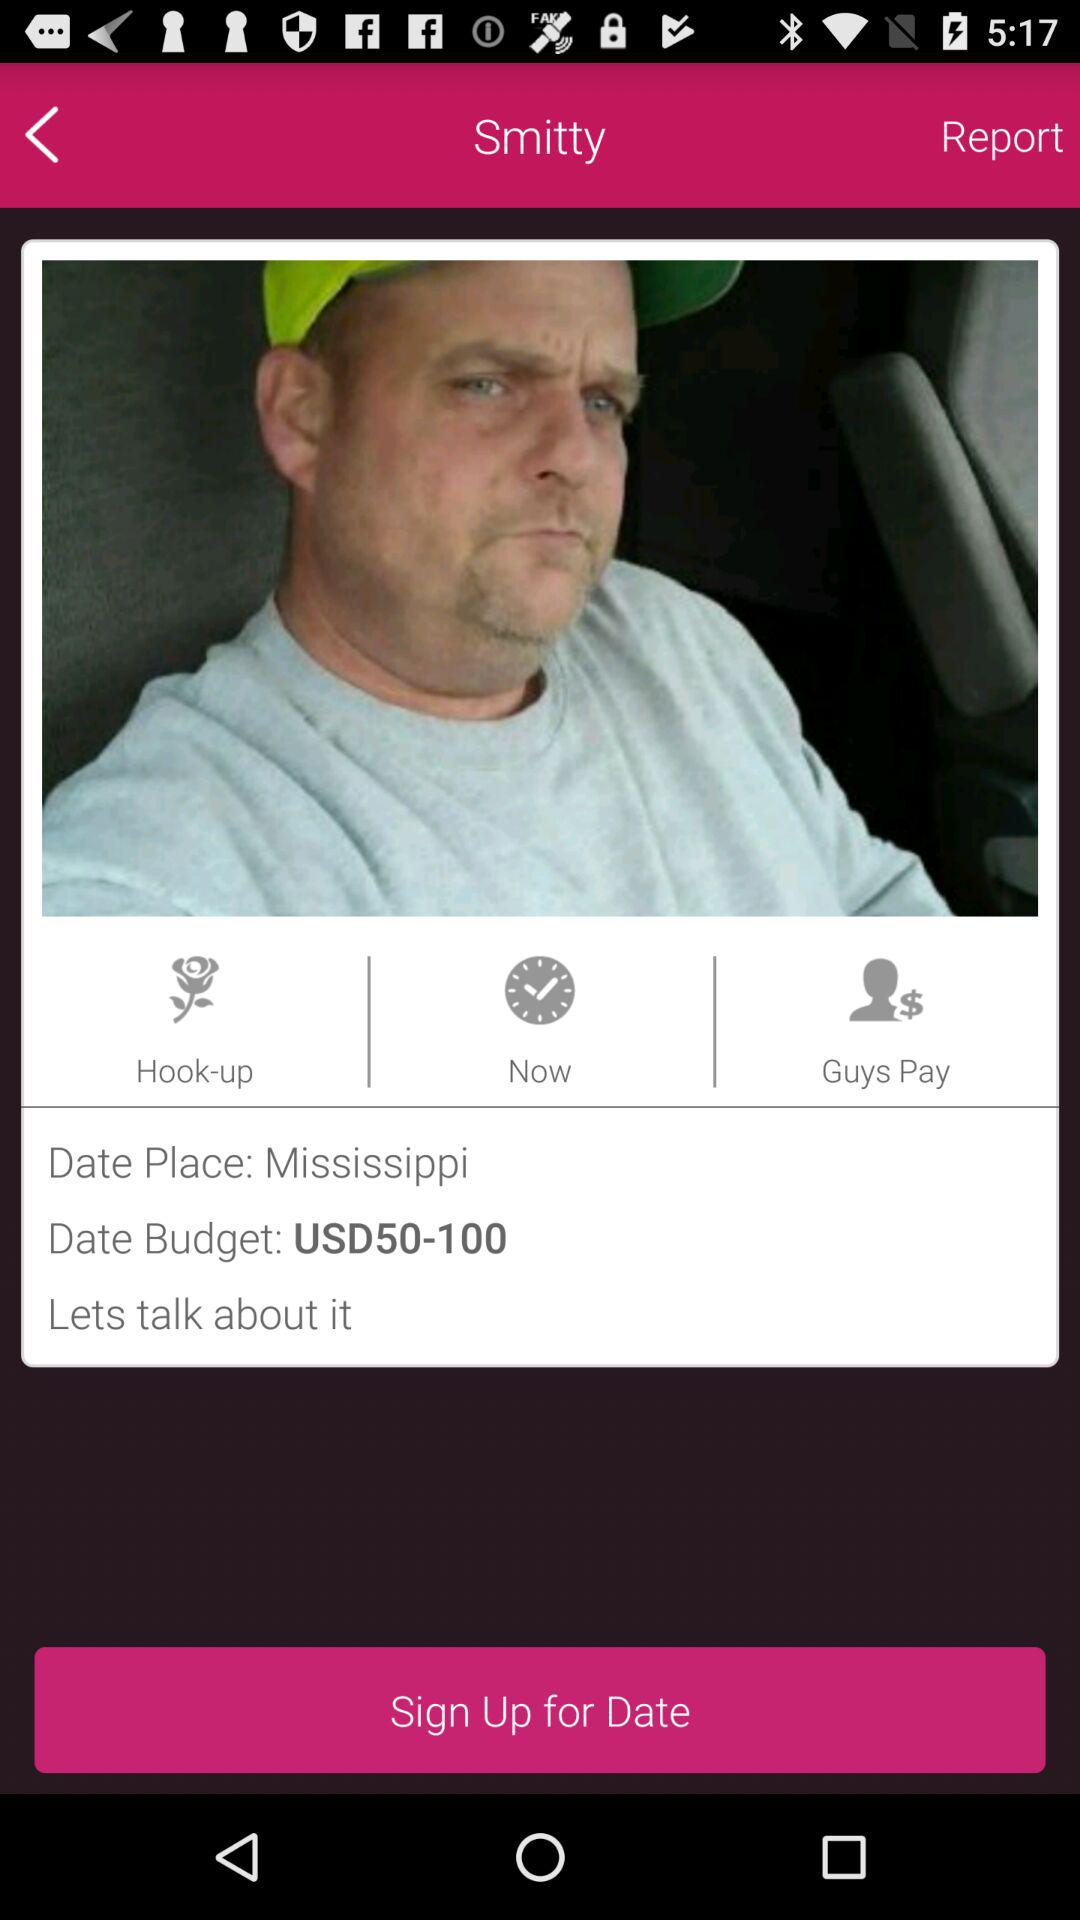What is the user name? The user name is Smitty. 